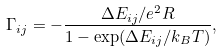Convert formula to latex. <formula><loc_0><loc_0><loc_500><loc_500>\Gamma _ { i j } = - \frac { \Delta E _ { i j } / e ^ { 2 } R } { 1 - \exp ( { \Delta E _ { i j } } / { k _ { B } T } ) } ,</formula> 